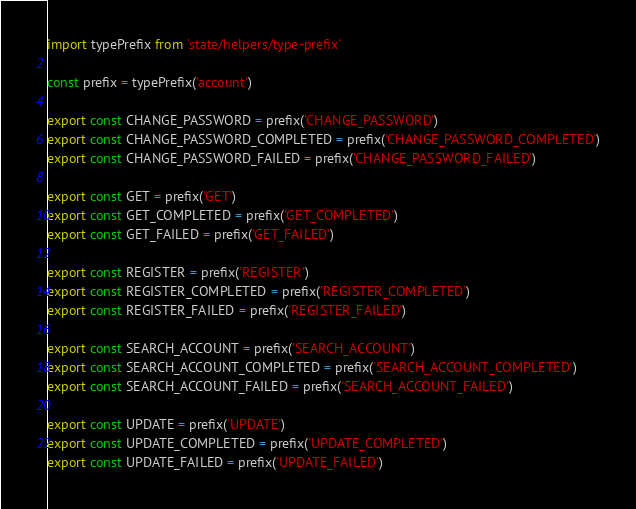<code> <loc_0><loc_0><loc_500><loc_500><_JavaScript_>import typePrefix from 'state/helpers/type-prefix'

const prefix = typePrefix('account')

export const CHANGE_PASSWORD = prefix('CHANGE_PASSWORD')
export const CHANGE_PASSWORD_COMPLETED = prefix('CHANGE_PASSWORD_COMPLETED')
export const CHANGE_PASSWORD_FAILED = prefix('CHANGE_PASSWORD_FAILED')

export const GET = prefix('GET')
export const GET_COMPLETED = prefix('GET_COMPLETED')
export const GET_FAILED = prefix('GET_FAILED')

export const REGISTER = prefix('REGISTER')
export const REGISTER_COMPLETED = prefix('REGISTER_COMPLETED')
export const REGISTER_FAILED = prefix('REGISTER_FAILED')

export const SEARCH_ACCOUNT = prefix('SEARCH_ACCOUNT')
export const SEARCH_ACCOUNT_COMPLETED = prefix('SEARCH_ACCOUNT_COMPLETED')
export const SEARCH_ACCOUNT_FAILED = prefix('SEARCH_ACCOUNT_FAILED')

export const UPDATE = prefix('UPDATE')
export const UPDATE_COMPLETED = prefix('UPDATE_COMPLETED')
export const UPDATE_FAILED = prefix('UPDATE_FAILED')
</code> 